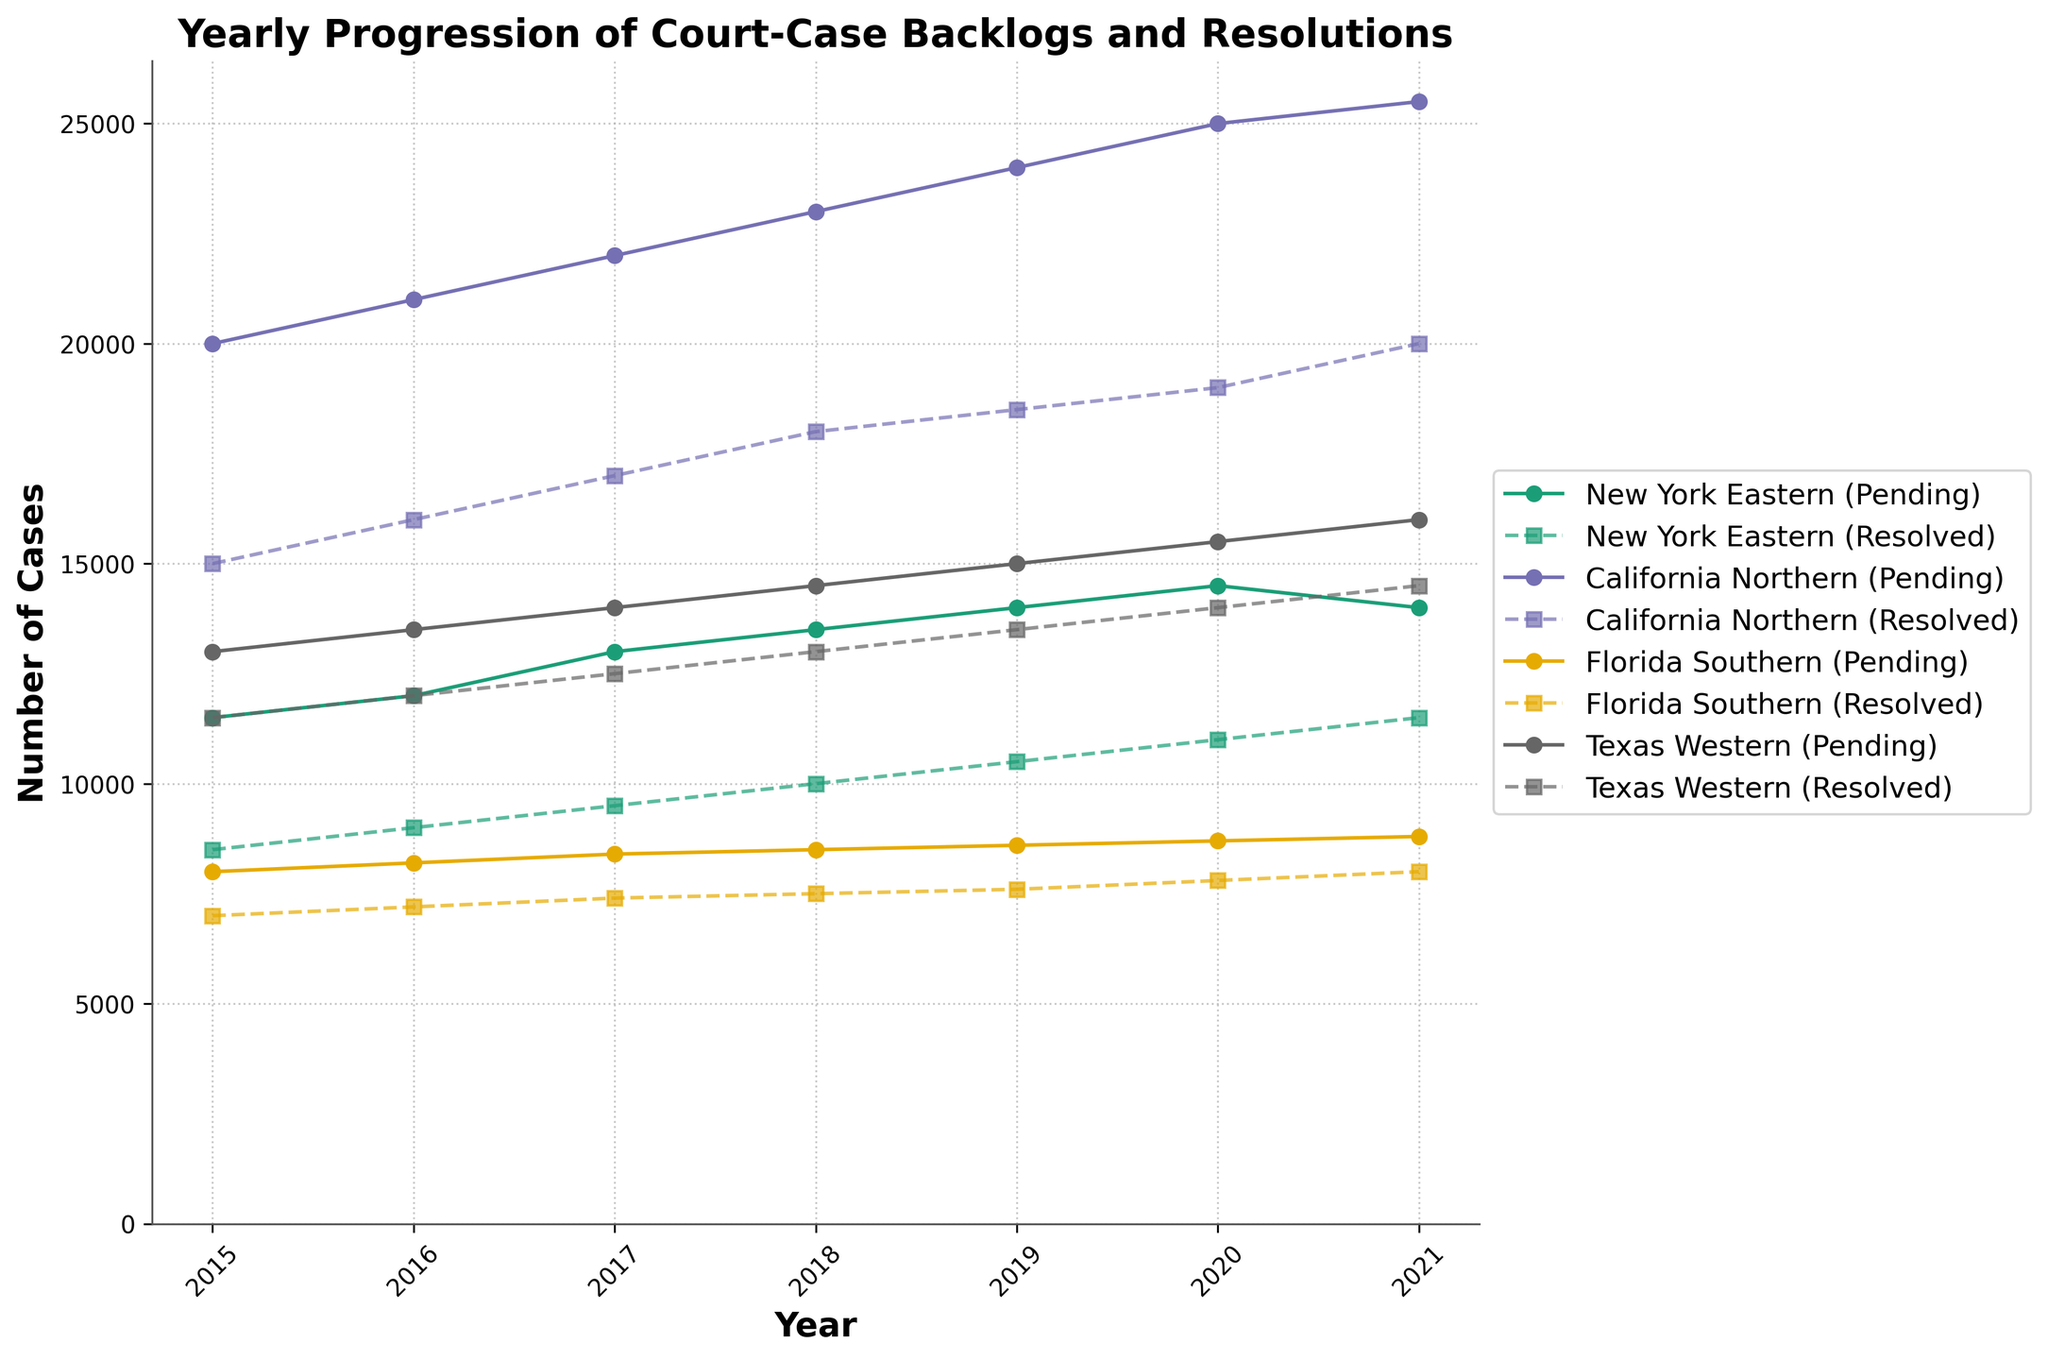What is the title of the figure? The title can be identified from the top of the figure. It is written in bold and large font.
Answer: Yearly Progression of Court-Case Backlogs and Resolutions How many jurisdictions are depicted in the figure? Each unique line pattern and color combination represents a different jurisdiction, visible in the legend on the right side of the figure.
Answer: Four Which jurisdiction had the highest number of pending cases in 2021? By locating the year 2021 along the x-axis and comparing the data points for pending cases among all jurisdictions, it can be discerned which jurisdiction has the highest value.
Answer: California Northern How did the number of pending cases in New York Eastern progress from 2015 to 2021? By following the line graph for New York Eastern from 2015 to 2021, one can observe how the data points for pending cases change over time.
Answer: Increased overall but decreased slightly in 2021 Which jurisdiction had more resolved cases in 2018: Texas Western or Florida Southern? By locating the year 2018 along the x-axis and comparing the markers for resolved cases in both jurisdictions, one can determine which jurisdiction has a higher value.
Answer: Texas Western What is the trend for pending cases in California Northern from 2015 to 2021? Analyzing the line representing pending cases for California Northern as it moves from 2015 to 2021, one can observe whether the values are generally increasing, decreasing, or steady.
Answer: Increasing What is the difference in the number of resolved cases between New York Eastern and Texas Western in 2020? Find the data points for resolved cases for both jurisdictions in 2020 and subtract the smaller value from the larger.
Answer: 1000 (Texas Western: 14000, New York Eastern: 11000) Which jurisdiction shows almost a constant increase in both pending and resolved cases from 2015 to 2021? By evaluating the trend lines for both pending and resolved cases for each jurisdiction, one can identify which has fairly uniform increments throughout these years.
Answer: Texas Western What is the average number of pending cases in Florida Southern between 2015 and 2021? Add the number of pending cases for each year from 2015 to 2021 in Florida Southern, then divide by the number of years (7).
Answer: 8471.43 Which year shows the highest number of resolved cases across all jurisdictions? By observing the trend lines for the resolved cases of each jurisdiction, locate the year where the highest peak appears.
Answer: 2021 